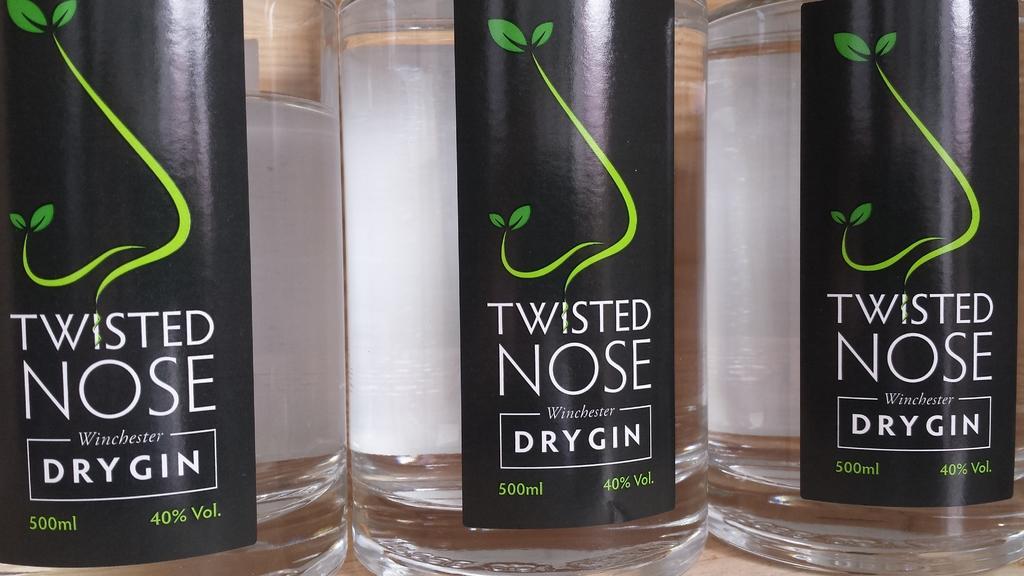How would you summarize this image in a sentence or two? In this picture there are three glass bottles and the bottles is covered with a sticker and the sticker is in black color. On the sticker there are leaves and the bottle is consists of 500 ml. 